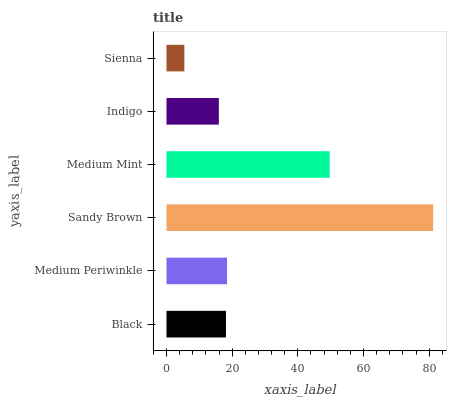Is Sienna the minimum?
Answer yes or no. Yes. Is Sandy Brown the maximum?
Answer yes or no. Yes. Is Medium Periwinkle the minimum?
Answer yes or no. No. Is Medium Periwinkle the maximum?
Answer yes or no. No. Is Medium Periwinkle greater than Black?
Answer yes or no. Yes. Is Black less than Medium Periwinkle?
Answer yes or no. Yes. Is Black greater than Medium Periwinkle?
Answer yes or no. No. Is Medium Periwinkle less than Black?
Answer yes or no. No. Is Medium Periwinkle the high median?
Answer yes or no. Yes. Is Black the low median?
Answer yes or no. Yes. Is Medium Mint the high median?
Answer yes or no. No. Is Indigo the low median?
Answer yes or no. No. 